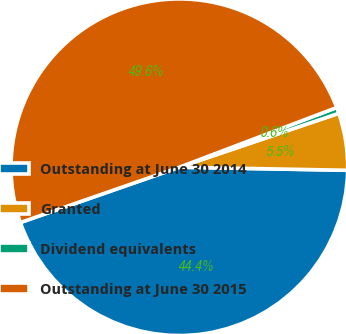Convert chart to OTSL. <chart><loc_0><loc_0><loc_500><loc_500><pie_chart><fcel>Outstanding at June 30 2014<fcel>Granted<fcel>Dividend equivalents<fcel>Outstanding at June 30 2015<nl><fcel>44.38%<fcel>5.48%<fcel>0.58%<fcel>49.55%<nl></chart> 